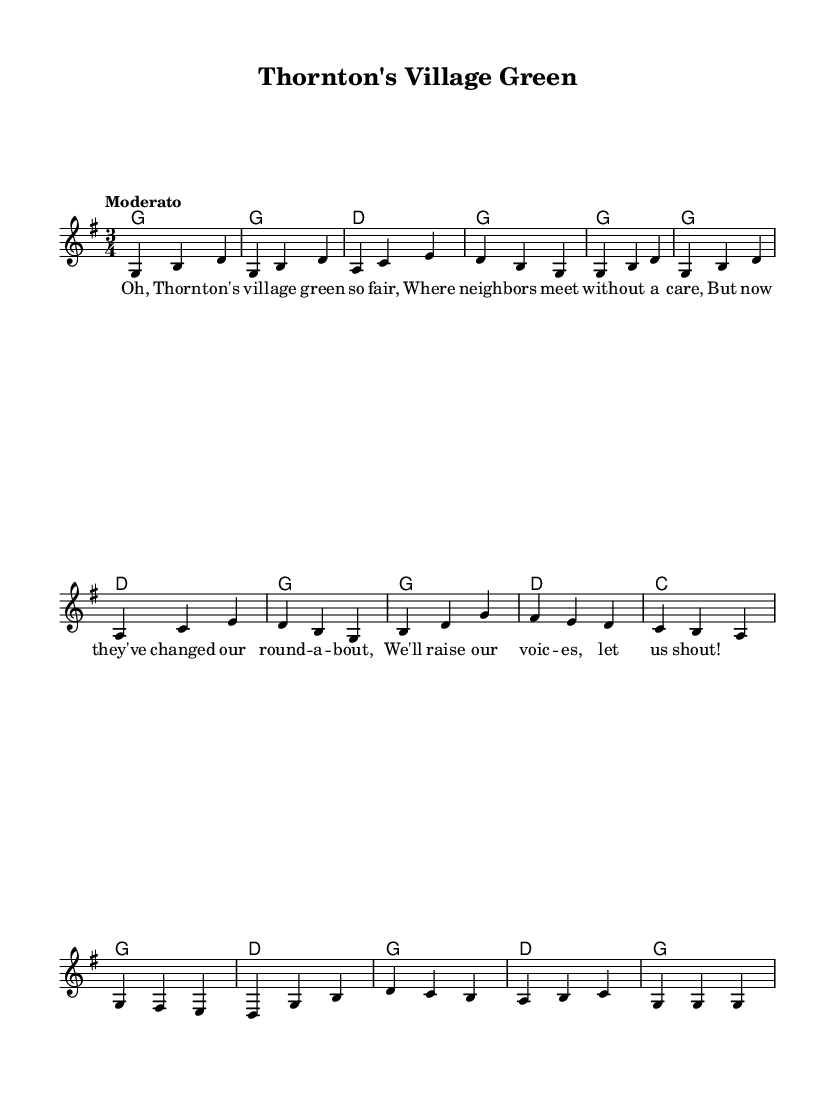What is the key signature of this music? The key signature is G major, which has one sharp (F#). This can be determined by identifying the key signature indicated at the beginning of the sheet music.
Answer: G major What is the time signature of this music? The time signature is 3/4, shown at the beginning of the score. This means there are three beats in each measure, and the quarter note receives one beat.
Answer: 3/4 What is the tempo marking of this music? The tempo marking is "Moderato," meaning a moderate pace. It is usually indicated in the score near the top in Italian terminology.
Answer: Moderato How many measures are in the melody? The melody consists of 12 measures, which can be counted by looking at the number of vertical bar lines in the sheet music.
Answer: 12 What is the last note of the melody? The last note of the melody is G. This is found by looking at the melody and identifying the note that occurs at the end of the score.
Answer: G What is the lyrical theme of the song? The lyrical theme revolves around the village green and community concerns, specifically expressing discontent with changes in the village. This theme is derived from the words provided in the lyric section of the music.
Answer: Community concerns How many chords are used in the harmonies section? The harmonies consist of four different chords: G, D, and C, where G appears multiple times. Counting the unique chords gives a total of three distinct chords.
Answer: 3 